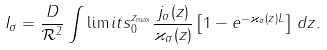Convert formula to latex. <formula><loc_0><loc_0><loc_500><loc_500>I _ { \sigma } = \frac { D } { \mathcal { R } ^ { 2 } } \int \lim i t s _ { 0 } ^ { z _ { \max } } \frac { j _ { \sigma } ( z ) } { \varkappa _ { \sigma } ( z ) } \left [ 1 - e ^ { - \varkappa _ { \sigma } ( z ) L } \right ] \, d z .</formula> 